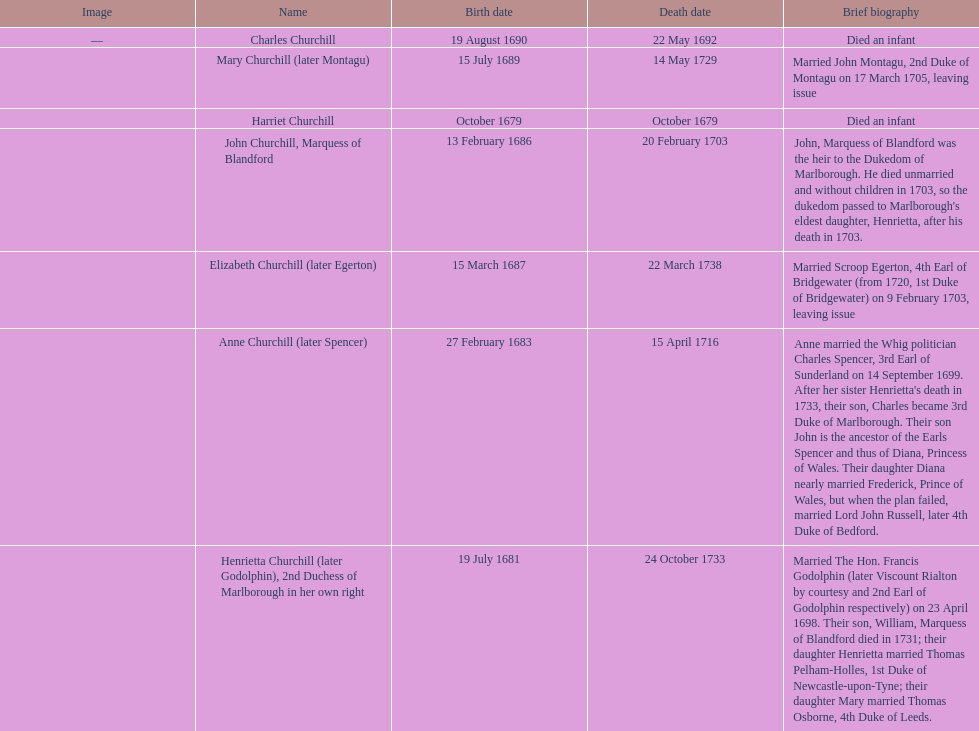How long did anne churchill/spencer live? 33. 